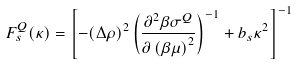Convert formula to latex. <formula><loc_0><loc_0><loc_500><loc_500>F ^ { Q } _ { s } ( \kappa ) = \left [ - ( \Delta \rho ) ^ { 2 } \left ( \frac { \partial ^ { 2 } \beta \sigma ^ { Q } } { \partial \left ( \beta \mu \right ) ^ { 2 } } \right ) ^ { - 1 } + b _ { s } \kappa ^ { 2 } \right ] ^ { - 1 }</formula> 